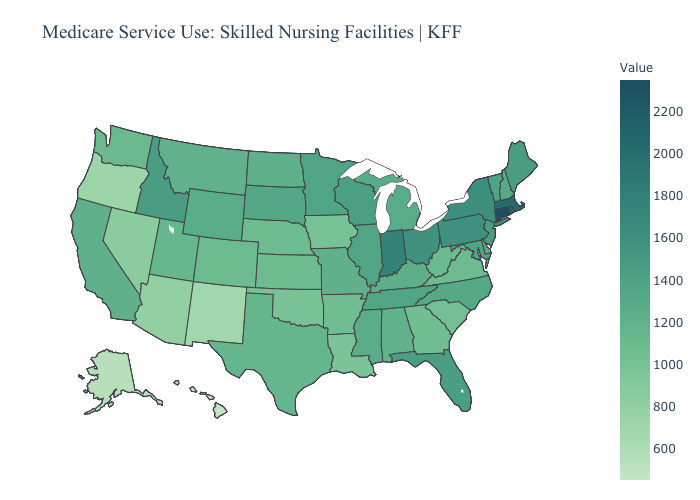Which states have the lowest value in the MidWest?
Quick response, please. Iowa. Does Connecticut have the highest value in the Northeast?
Quick response, please. Yes. Among the states that border Wisconsin , which have the highest value?
Give a very brief answer. Minnesota. Does Hawaii have the lowest value in the USA?
Be succinct. Yes. Which states have the lowest value in the South?
Quick response, please. Louisiana. Does the map have missing data?
Short answer required. No. 